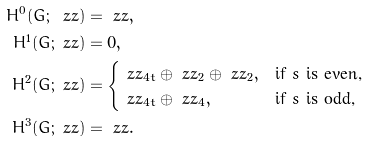Convert formula to latex. <formula><loc_0><loc_0><loc_500><loc_500>H ^ { 0 } ( G ; \ z z ) & = \ z z , \\ H ^ { 1 } ( G ; \ z z ) & = 0 , \\ H ^ { 2 } ( G ; \ z z ) & = \begin{cases} \ z z _ { 4 t } \oplus \ z z _ { 2 } \oplus \ z z _ { 2 } , & \text {if $s$ is even,} \\ \ z z _ { 4 t } \oplus \ z z _ { 4 } , & \text {if $s$ is odd,} \\ \end{cases} \\ H ^ { 3 } ( G ; \ z z ) & = \ z z .</formula> 